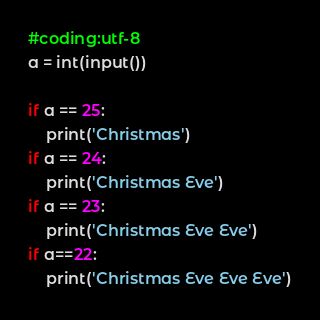Convert code to text. <code><loc_0><loc_0><loc_500><loc_500><_Python_>#coding:utf-8
a = int(input())

if a == 25:
	print('Christmas')
if a == 24:
	print('Christmas Eve')
if a == 23:
	print('Christmas Eve Eve')
if a==22:
	print('Christmas Eve Eve Eve')</code> 